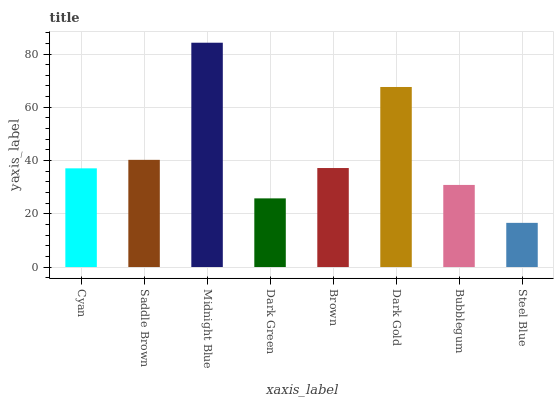Is Steel Blue the minimum?
Answer yes or no. Yes. Is Midnight Blue the maximum?
Answer yes or no. Yes. Is Saddle Brown the minimum?
Answer yes or no. No. Is Saddle Brown the maximum?
Answer yes or no. No. Is Saddle Brown greater than Cyan?
Answer yes or no. Yes. Is Cyan less than Saddle Brown?
Answer yes or no. Yes. Is Cyan greater than Saddle Brown?
Answer yes or no. No. Is Saddle Brown less than Cyan?
Answer yes or no. No. Is Brown the high median?
Answer yes or no. Yes. Is Cyan the low median?
Answer yes or no. Yes. Is Dark Gold the high median?
Answer yes or no. No. Is Brown the low median?
Answer yes or no. No. 